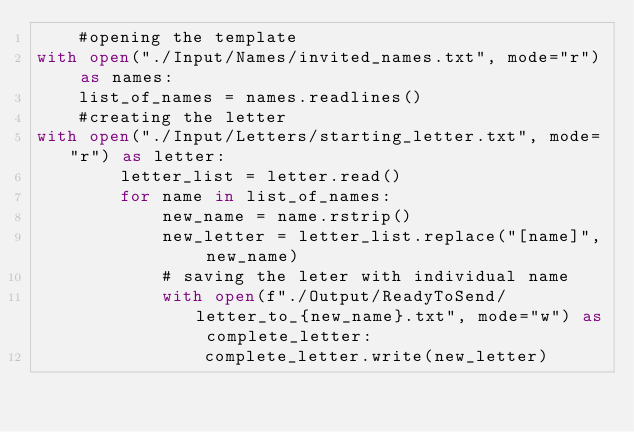<code> <loc_0><loc_0><loc_500><loc_500><_Python_>    #opening the template
with open("./Input/Names/invited_names.txt", mode="r") as names:
    list_of_names = names.readlines()
    #creating the letter
with open("./Input/Letters/starting_letter.txt", mode="r") as letter:
        letter_list = letter.read()
        for name in list_of_names:
            new_name = name.rstrip()
            new_letter = letter_list.replace("[name]", new_name)
            # saving the leter with individual name
            with open(f"./Output/ReadyToSend/letter_to_{new_name}.txt", mode="w") as complete_letter: 
                complete_letter.write(new_letter)
</code> 